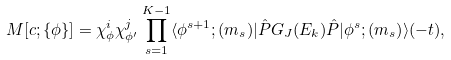<formula> <loc_0><loc_0><loc_500><loc_500>M [ { c } ; \{ \phi \} ] = \chi ^ { i } _ { \phi } \chi ^ { j } _ { \phi ^ { \prime } } \prod _ { s = 1 } ^ { K - 1 } \langle \phi ^ { s + 1 } ; { ( m _ { s } ) } | \hat { P } G _ { J } ( E _ { k } ) \hat { P } | \phi ^ { s } ; { ( m _ { s } ) } \rangle ( - t ) ,</formula> 